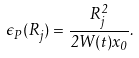<formula> <loc_0><loc_0><loc_500><loc_500>\epsilon _ { P } ( R _ { j } ) = \frac { R _ { j } ^ { 2 } } { 2 W ( t ) x _ { 0 } } .</formula> 